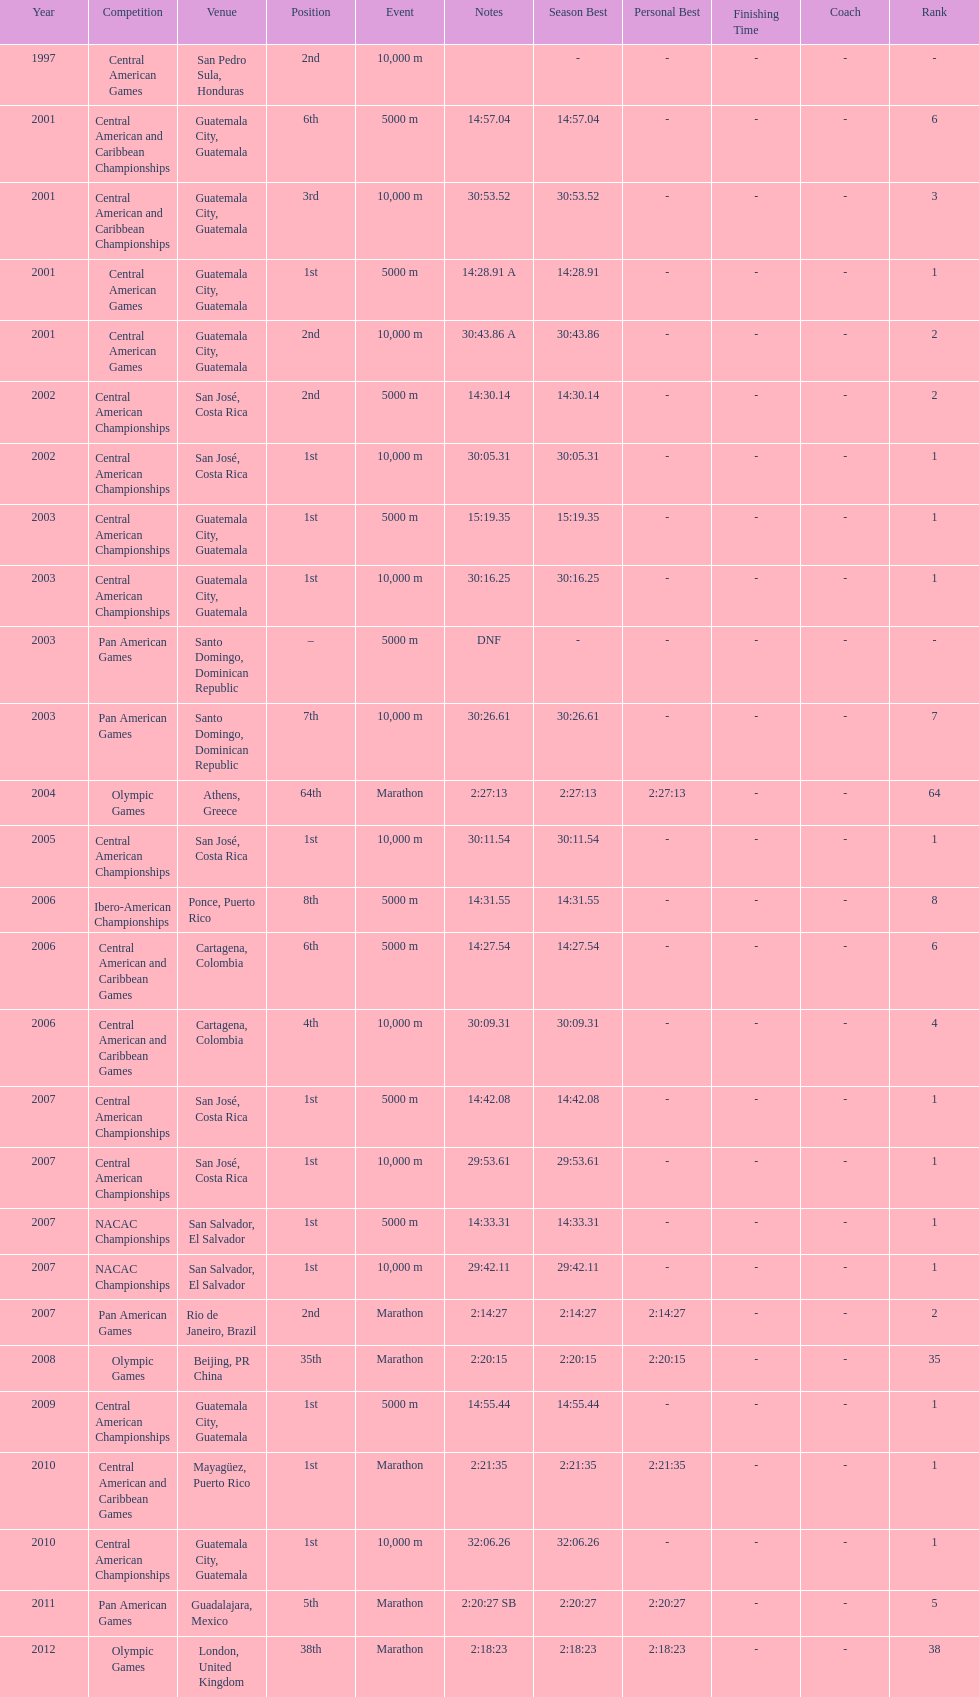What competition did this competitor compete at after participating in the central american games in 2001? Central American Championships. Would you mind parsing the complete table? {'header': ['Year', 'Competition', 'Venue', 'Position', 'Event', 'Notes', 'Season Best', 'Personal Best', 'Finishing Time', 'Coach', 'Rank'], 'rows': [['1997', 'Central American Games', 'San Pedro Sula, Honduras', '2nd', '10,000 m', '', '-', '-', '-', '-', '-'], ['2001', 'Central American and Caribbean Championships', 'Guatemala City, Guatemala', '6th', '5000 m', '14:57.04', '14:57.04', '-', '-', '-', '6'], ['2001', 'Central American and Caribbean Championships', 'Guatemala City, Guatemala', '3rd', '10,000 m', '30:53.52', '30:53.52', '-', '-', '-', '3'], ['2001', 'Central American Games', 'Guatemala City, Guatemala', '1st', '5000 m', '14:28.91 A', '14:28.91', '-', '-', '-', '1'], ['2001', 'Central American Games', 'Guatemala City, Guatemala', '2nd', '10,000 m', '30:43.86 A', '30:43.86', '-', '-', '-', '2'], ['2002', 'Central American Championships', 'San José, Costa Rica', '2nd', '5000 m', '14:30.14', '14:30.14', '-', '-', '-', '2'], ['2002', 'Central American Championships', 'San José, Costa Rica', '1st', '10,000 m', '30:05.31', '30:05.31', '-', '-', '-', '1'], ['2003', 'Central American Championships', 'Guatemala City, Guatemala', '1st', '5000 m', '15:19.35', '15:19.35', '-', '-', '-', '1'], ['2003', 'Central American Championships', 'Guatemala City, Guatemala', '1st', '10,000 m', '30:16.25', '30:16.25', '-', '-', '-', '1'], ['2003', 'Pan American Games', 'Santo Domingo, Dominican Republic', '–', '5000 m', 'DNF', '-', '-', '-', '-', '-'], ['2003', 'Pan American Games', 'Santo Domingo, Dominican Republic', '7th', '10,000 m', '30:26.61', '30:26.61', '-', '-', '-', '7'], ['2004', 'Olympic Games', 'Athens, Greece', '64th', 'Marathon', '2:27:13', '2:27:13', '2:27:13', '-', '-', '64'], ['2005', 'Central American Championships', 'San José, Costa Rica', '1st', '10,000 m', '30:11.54', '30:11.54', '-', '-', '-', '1'], ['2006', 'Ibero-American Championships', 'Ponce, Puerto Rico', '8th', '5000 m', '14:31.55', '14:31.55', '-', '-', '-', '8'], ['2006', 'Central American and Caribbean Games', 'Cartagena, Colombia', '6th', '5000 m', '14:27.54', '14:27.54', '-', '-', '-', '6'], ['2006', 'Central American and Caribbean Games', 'Cartagena, Colombia', '4th', '10,000 m', '30:09.31', '30:09.31', '-', '-', '-', '4'], ['2007', 'Central American Championships', 'San José, Costa Rica', '1st', '5000 m', '14:42.08', '14:42.08', '-', '-', '-', '1'], ['2007', 'Central American Championships', 'San José, Costa Rica', '1st', '10,000 m', '29:53.61', '29:53.61', '-', '-', '-', '1'], ['2007', 'NACAC Championships', 'San Salvador, El Salvador', '1st', '5000 m', '14:33.31', '14:33.31', '-', '-', '-', '1'], ['2007', 'NACAC Championships', 'San Salvador, El Salvador', '1st', '10,000 m', '29:42.11', '29:42.11', '-', '-', '-', '1'], ['2007', 'Pan American Games', 'Rio de Janeiro, Brazil', '2nd', 'Marathon', '2:14:27', '2:14:27', '2:14:27', '-', '-', '2'], ['2008', 'Olympic Games', 'Beijing, PR China', '35th', 'Marathon', '2:20:15', '2:20:15', '2:20:15', '-', '-', '35'], ['2009', 'Central American Championships', 'Guatemala City, Guatemala', '1st', '5000 m', '14:55.44', '14:55.44', '-', '-', '-', '1'], ['2010', 'Central American and Caribbean Games', 'Mayagüez, Puerto Rico', '1st', 'Marathon', '2:21:35', '2:21:35', '2:21:35', '-', '-', '1'], ['2010', 'Central American Championships', 'Guatemala City, Guatemala', '1st', '10,000 m', '32:06.26', '32:06.26', '-', '-', '-', '1'], ['2011', 'Pan American Games', 'Guadalajara, Mexico', '5th', 'Marathon', '2:20:27 SB', '2:20:27', '2:20:27', '-', '-', '5'], ['2012', 'Olympic Games', 'London, United Kingdom', '38th', 'Marathon', '2:18:23', '2:18:23', '2:18:23', '-', '-', '38']]} 